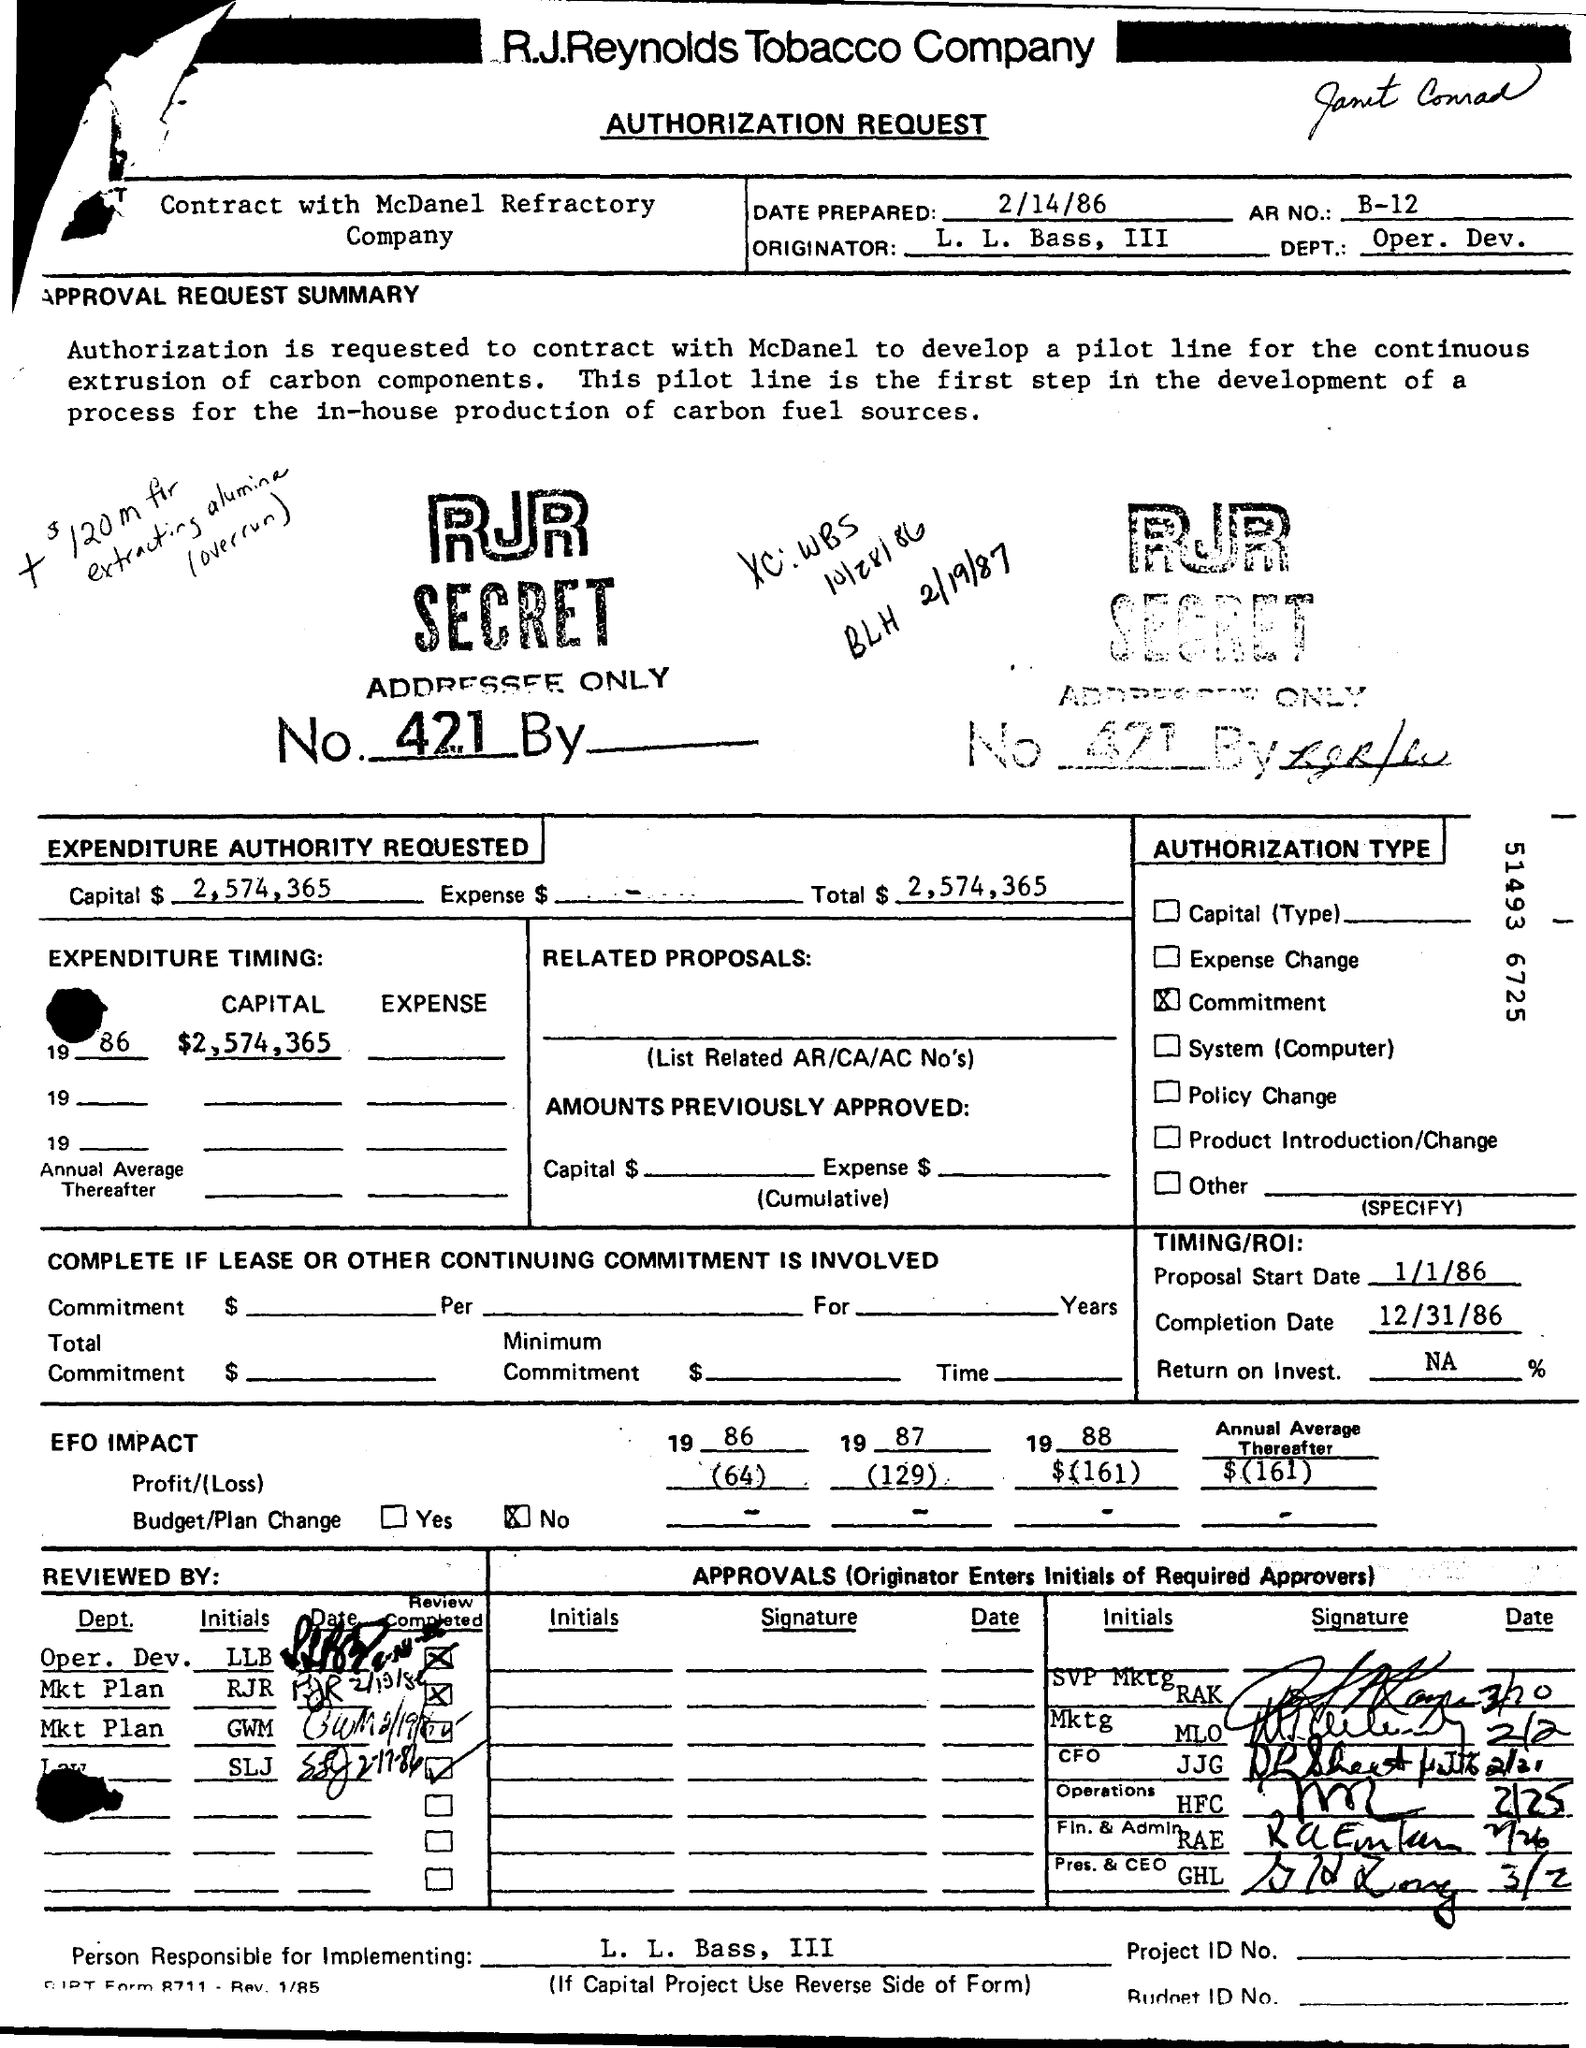Can you provide details about the project mentioned in the document? The project outlined in the document involves contracting McDaniel Refractory Company to develop a pilot line for the continuous extrusion of components. This pilot line is part of a broader initiative to produce carbon fuel sources in-house, aiming to enhance operational capabilities and sustainability in energy sourcing. What does the 'SECRET' stamp on the document indicate? The 'SECRET' stamp on the document indicates that the information contained within is confidential. This label typically denotes that access to the document is strictly controlled and limited to individuals authorized by the company, due to the sensitive nature of the project involved. 